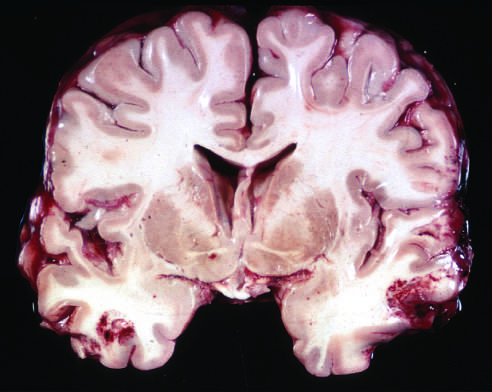what are present in both temporal lobes, with areas of hemorrhage and tissue disruption?
Answer the question using a single word or phrase. Acute contusions 